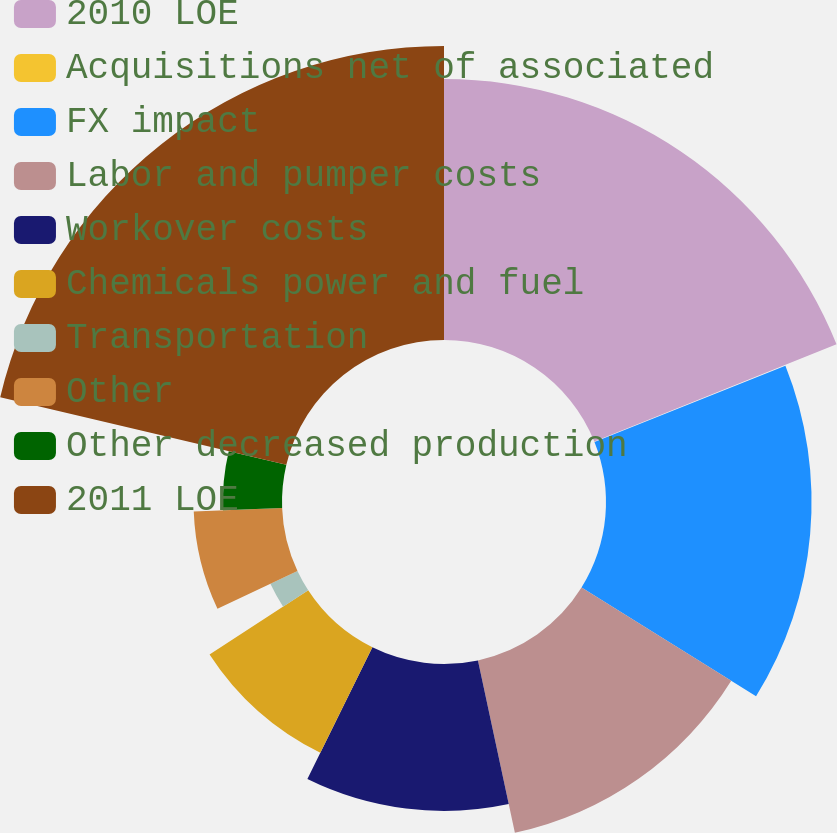Convert chart. <chart><loc_0><loc_0><loc_500><loc_500><pie_chart><fcel>2010 LOE<fcel>Acquisitions net of associated<fcel>FX impact<fcel>Labor and pumper costs<fcel>Workover costs<fcel>Chemicals power and fuel<fcel>Transportation<fcel>Other<fcel>Other decreased production<fcel>2011 LOE<nl><fcel>18.92%<fcel>0.04%<fcel>14.9%<fcel>12.78%<fcel>10.65%<fcel>8.53%<fcel>2.17%<fcel>6.41%<fcel>4.29%<fcel>21.31%<nl></chart> 